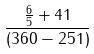<formula> <loc_0><loc_0><loc_500><loc_500>\frac { \frac { 6 } { 5 } + 4 1 } { ( 3 6 0 - 2 5 1 ) }</formula> 